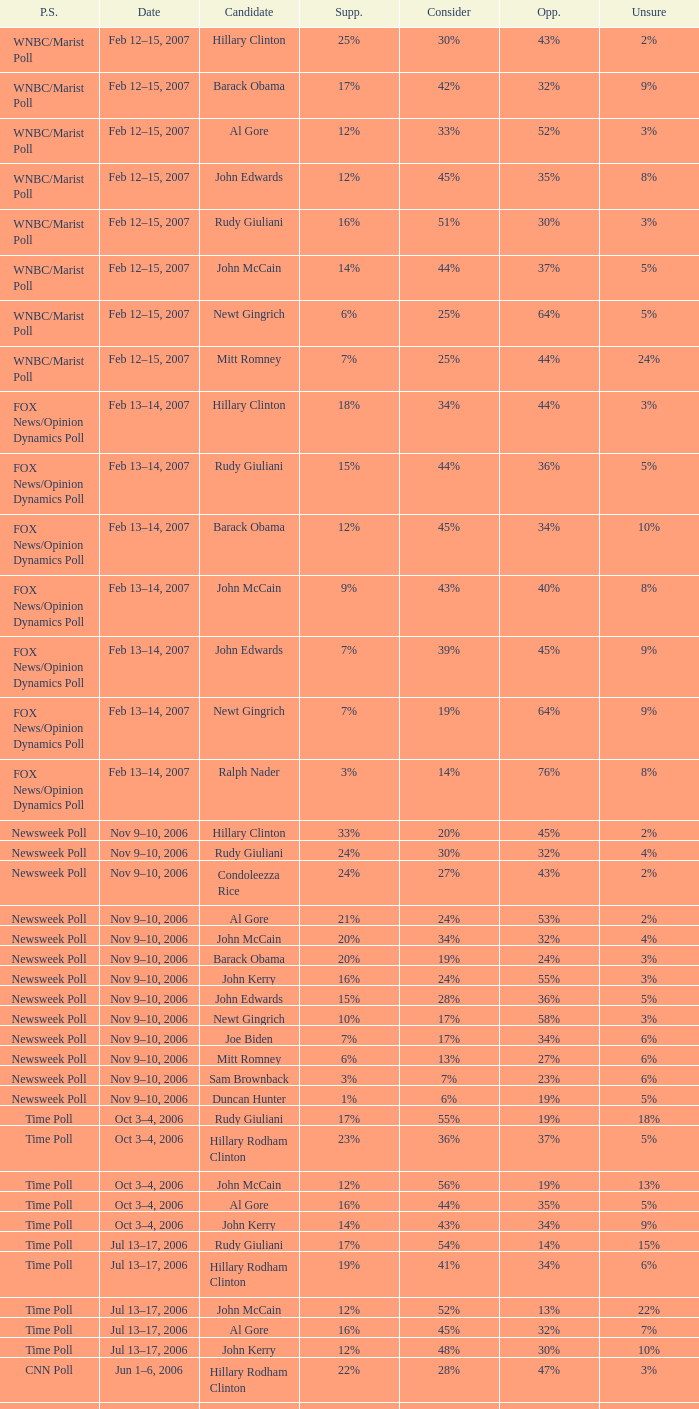What percentage of people were opposed to the candidate based on the Time Poll poll that showed 6% of people were unsure? 34%. 